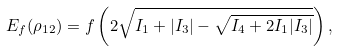Convert formula to latex. <formula><loc_0><loc_0><loc_500><loc_500>E _ { f } ( \rho _ { 1 2 } ) = f \left ( 2 \sqrt { I _ { 1 } + | I _ { 3 } | - \sqrt { I _ { 4 } + 2 I _ { 1 } | I _ { 3 } | } } \right ) ,</formula> 